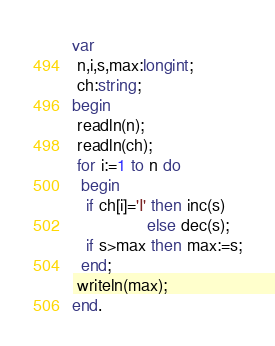Convert code to text. <code><loc_0><loc_0><loc_500><loc_500><_Pascal_>var
 n,i,s,max:longint;
 ch:string;
begin
 readln(n);
 readln(ch);
 for i:=1 to n do
  begin
   if ch[i]='I' then inc(s)
                else dec(s);
   if s>max then max:=s;
  end;
 writeln(max);
end.</code> 